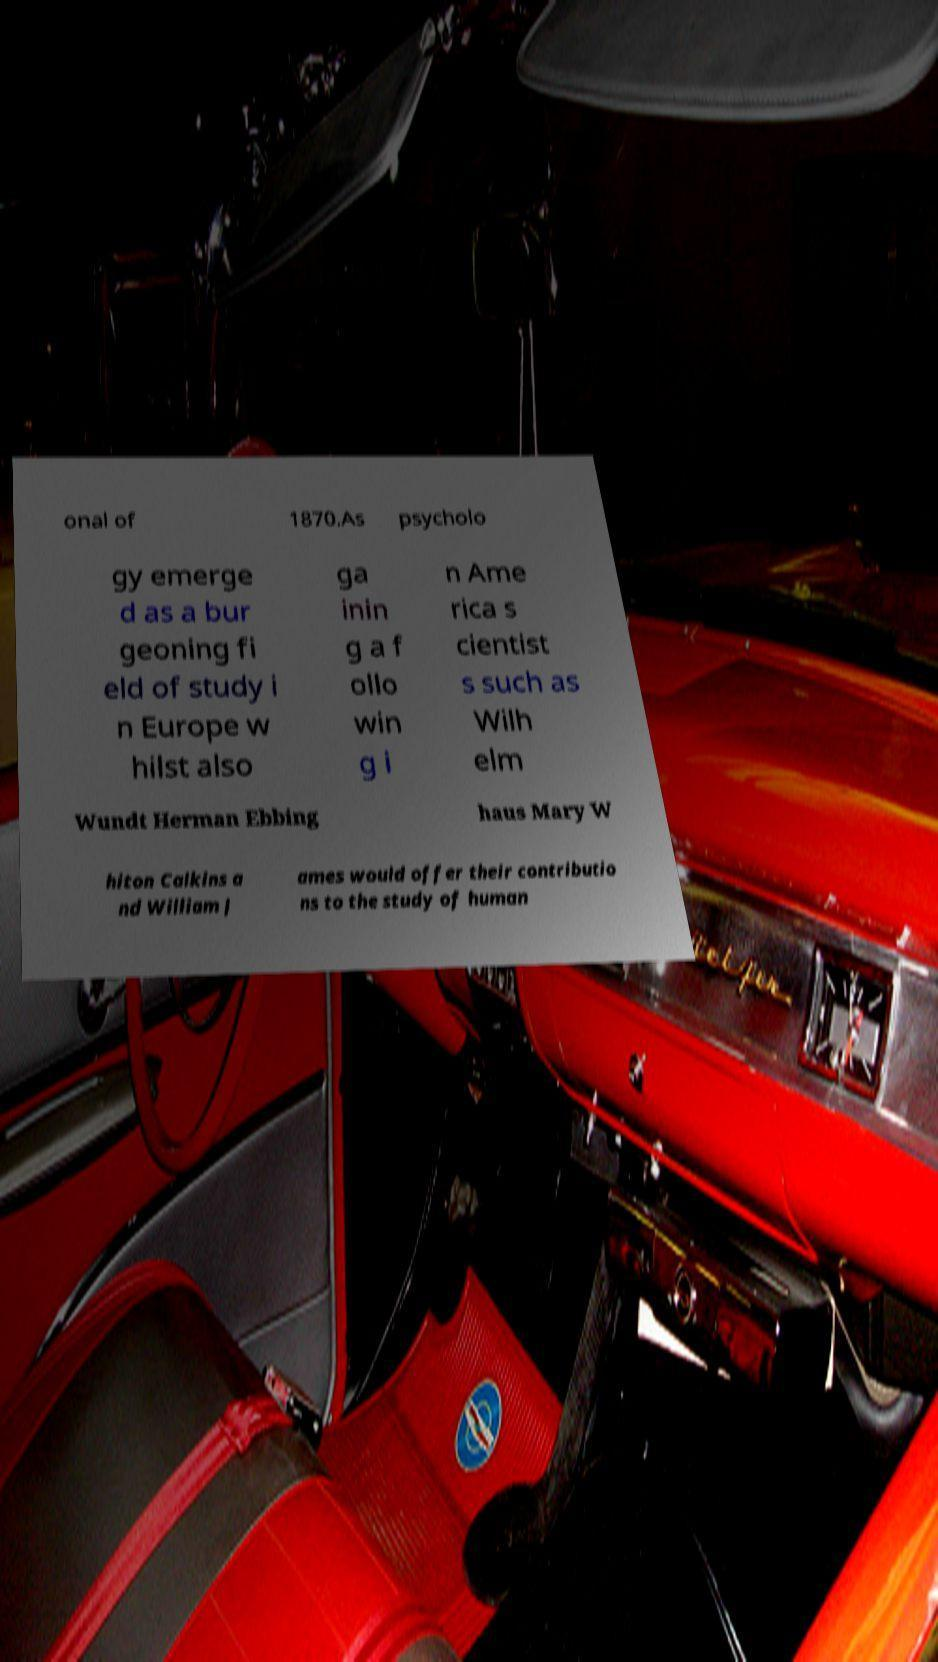Please identify and transcribe the text found in this image. onal of 1870.As psycholo gy emerge d as a bur geoning fi eld of study i n Europe w hilst also ga inin g a f ollo win g i n Ame rica s cientist s such as Wilh elm Wundt Herman Ebbing haus Mary W hiton Calkins a nd William J ames would offer their contributio ns to the study of human 